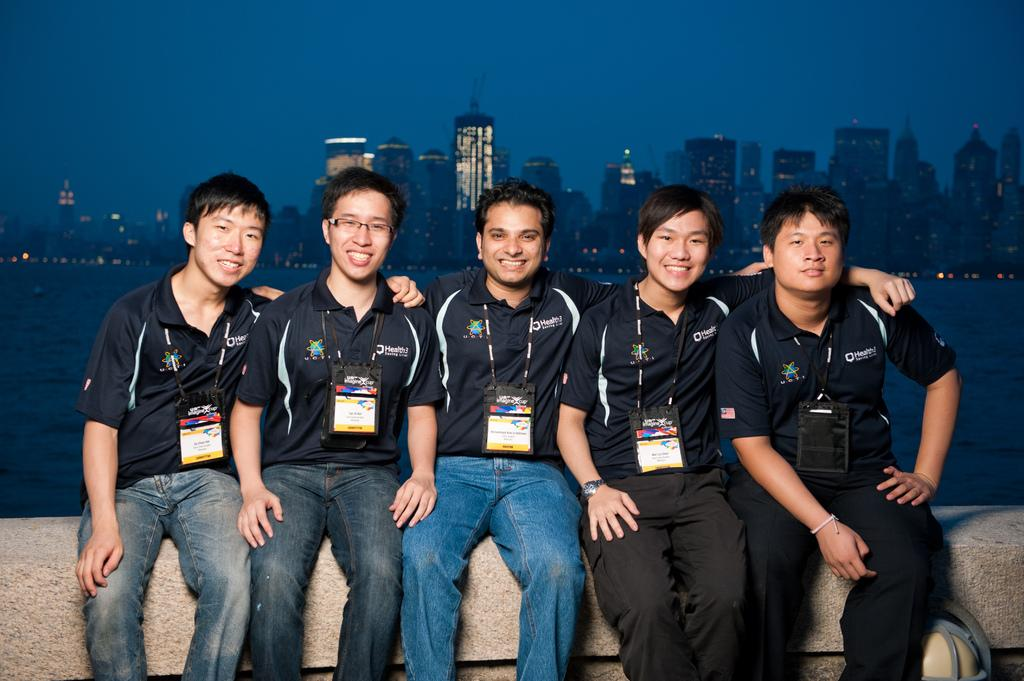What are the people in the foreground of the image doing? The people are sitting on a stone surface in the foreground. What can be seen in the middle of the image? There is a water body in the middle of the image. What is visible in the background of the image? There are buildings and the sky in the background of the image. Can you solve the riddle that is written on the watch in the image? There is no watch present in the image, so there is no riddle to solve. How many boats are docked at the dock in the image? There is no dock or boats present in the image. 